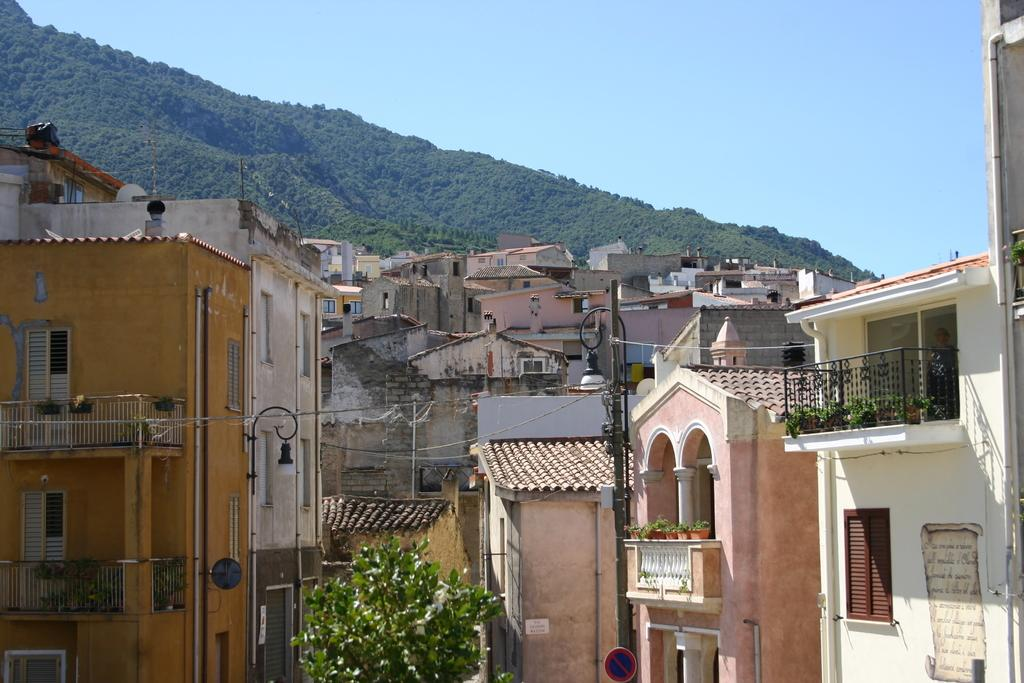What type of natural element can be seen in the image? There is a tree in the image. What type of man-made structures are present in the image? There are buildings in the image. What geographical feature is visible at the top of the image? There is a hill visible at the top of the image. How many giants can be seen walking on the hill in the image? There are no giants present in the image; it features a tree, buildings, and a hill. What type of bottle is visible on the tree in the image? There is no bottle present on the tree in the image. 